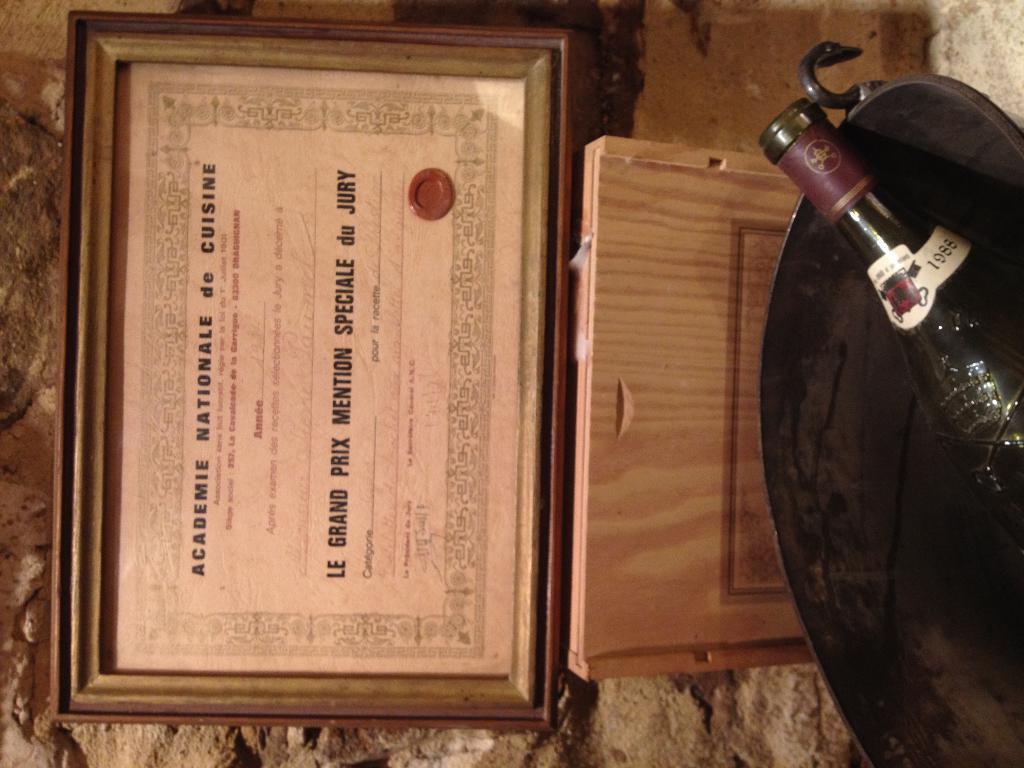Could you give a brief overview of what you see in this image? In this picture we can see frame and in frame there is certificate and aside to that there is a bottle placed in the bucket and here we can see some rock wall. 